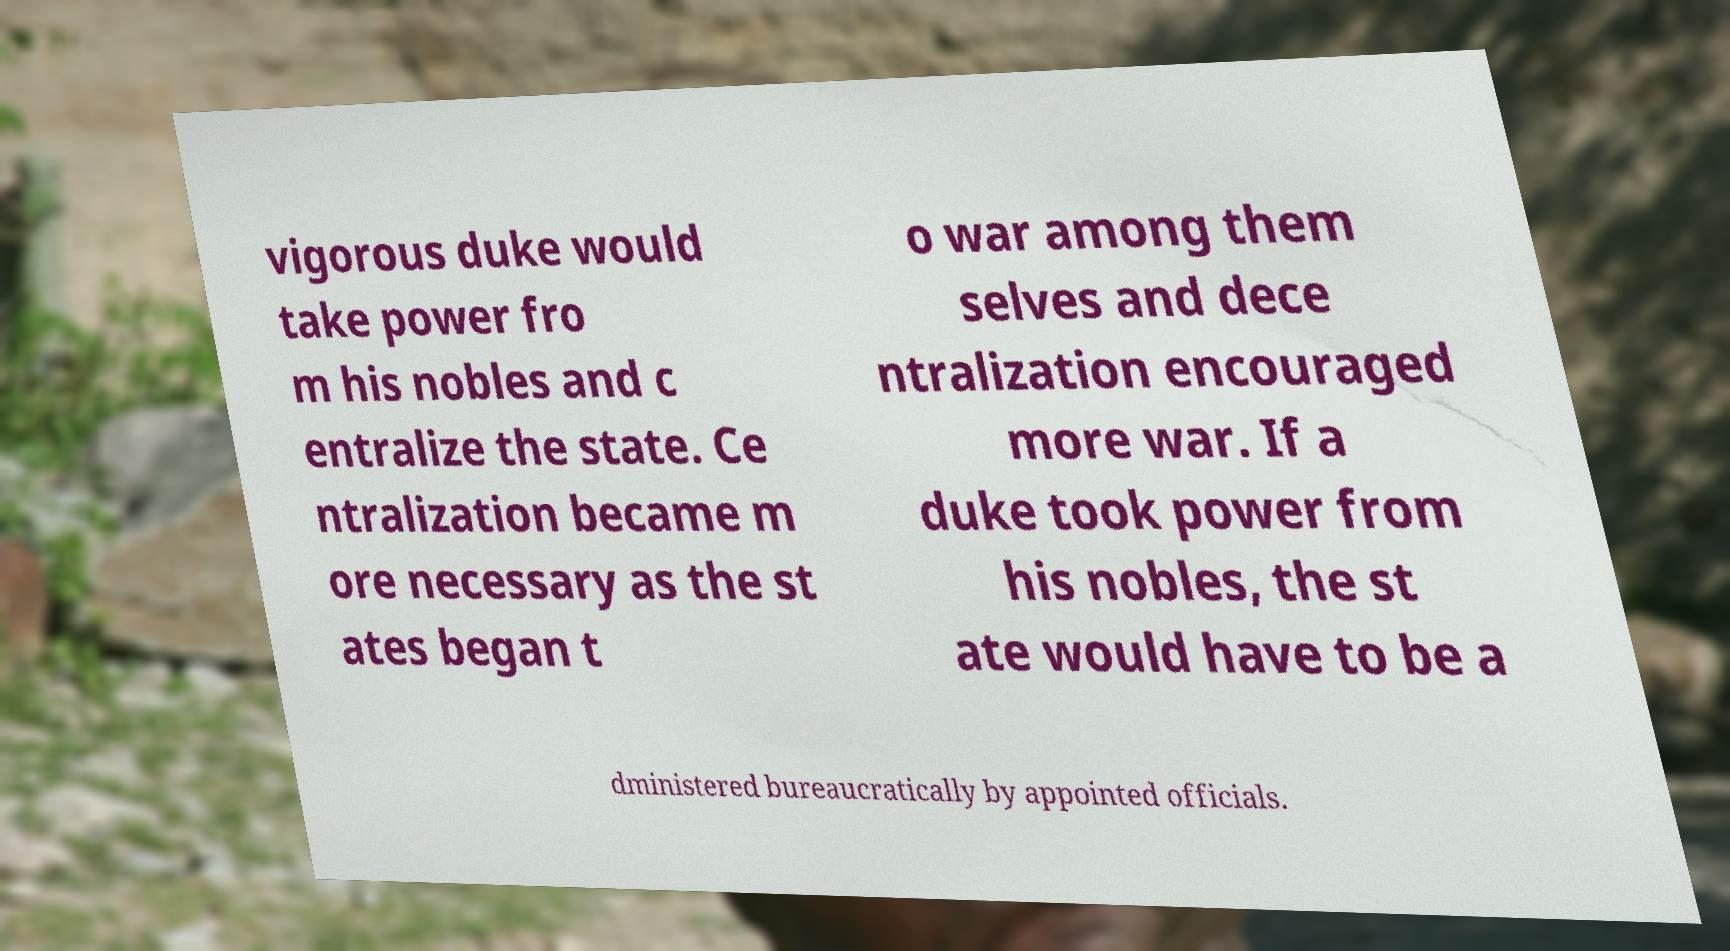Can you read and provide the text displayed in the image?This photo seems to have some interesting text. Can you extract and type it out for me? vigorous duke would take power fro m his nobles and c entralize the state. Ce ntralization became m ore necessary as the st ates began t o war among them selves and dece ntralization encouraged more war. If a duke took power from his nobles, the st ate would have to be a dministered bureaucratically by appointed officials. 